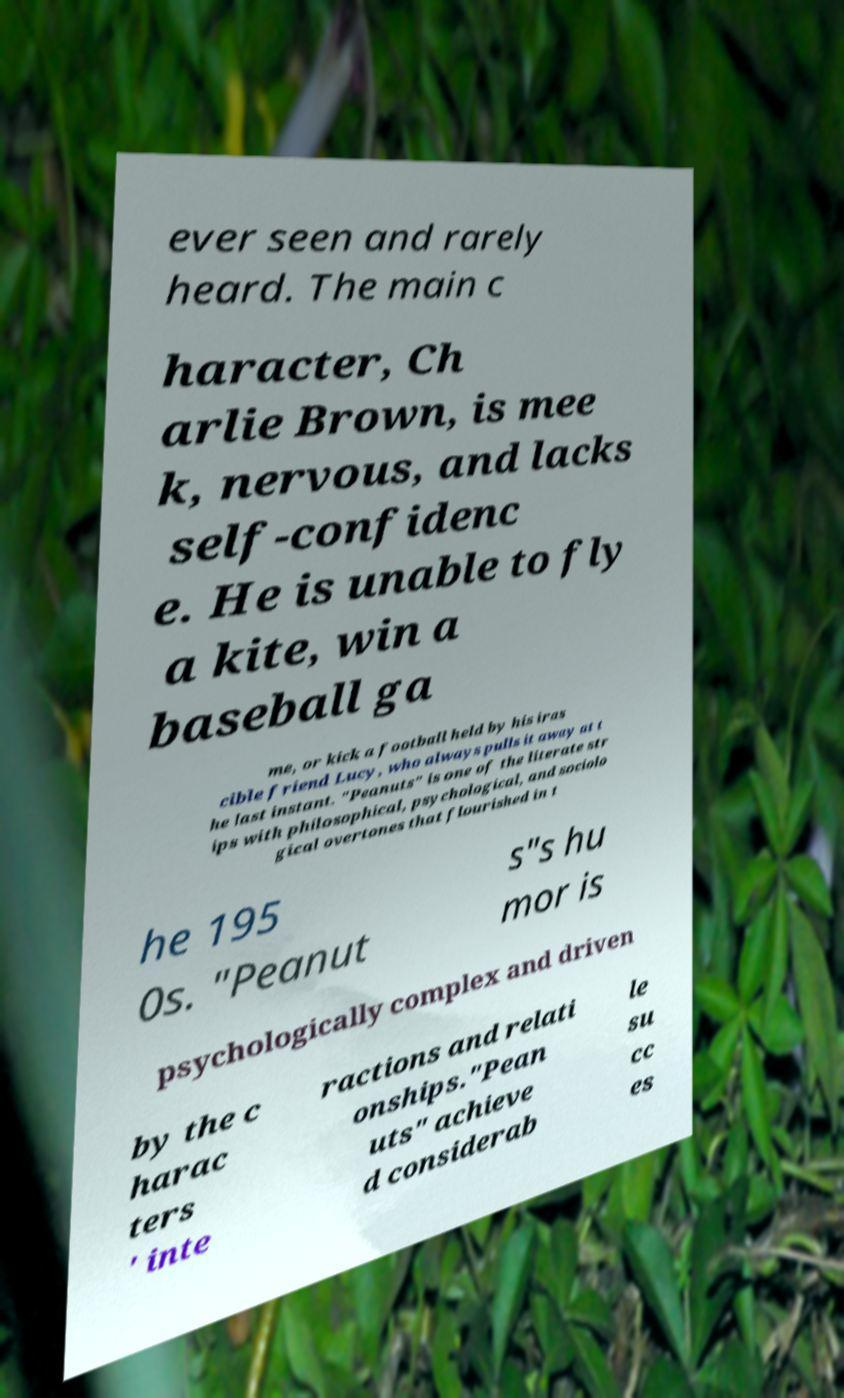Can you read and provide the text displayed in the image?This photo seems to have some interesting text. Can you extract and type it out for me? ever seen and rarely heard. The main c haracter, Ch arlie Brown, is mee k, nervous, and lacks self-confidenc e. He is unable to fly a kite, win a baseball ga me, or kick a football held by his iras cible friend Lucy, who always pulls it away at t he last instant. "Peanuts" is one of the literate str ips with philosophical, psychological, and sociolo gical overtones that flourished in t he 195 0s. "Peanut s"s hu mor is psychologically complex and driven by the c harac ters ' inte ractions and relati onships."Pean uts" achieve d considerab le su cc es 